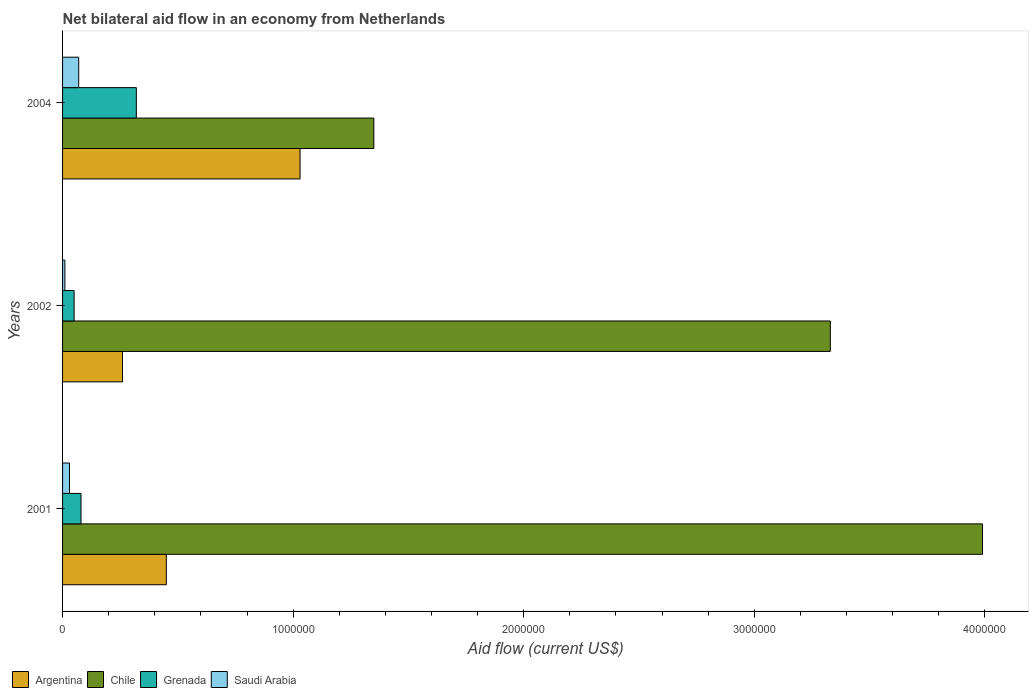How many groups of bars are there?
Your response must be concise. 3. Are the number of bars on each tick of the Y-axis equal?
Keep it short and to the point. Yes. What is the label of the 1st group of bars from the top?
Your answer should be very brief. 2004. In how many cases, is the number of bars for a given year not equal to the number of legend labels?
Provide a short and direct response. 0. What is the net bilateral aid flow in Argentina in 2004?
Ensure brevity in your answer.  1.03e+06. Across all years, what is the minimum net bilateral aid flow in Saudi Arabia?
Provide a short and direct response. 10000. In which year was the net bilateral aid flow in Argentina maximum?
Keep it short and to the point. 2004. What is the total net bilateral aid flow in Chile in the graph?
Keep it short and to the point. 8.67e+06. What is the difference between the net bilateral aid flow in Chile in 2004 and the net bilateral aid flow in Saudi Arabia in 2002?
Your answer should be very brief. 1.34e+06. What is the average net bilateral aid flow in Chile per year?
Keep it short and to the point. 2.89e+06. In the year 2001, what is the difference between the net bilateral aid flow in Argentina and net bilateral aid flow in Saudi Arabia?
Make the answer very short. 4.20e+05. In how many years, is the net bilateral aid flow in Chile greater than 1000000 US$?
Keep it short and to the point. 3. What is the ratio of the net bilateral aid flow in Grenada in 2001 to that in 2002?
Offer a very short reply. 1.6. Is the net bilateral aid flow in Saudi Arabia in 2001 less than that in 2002?
Provide a short and direct response. No. Is the difference between the net bilateral aid flow in Argentina in 2001 and 2004 greater than the difference between the net bilateral aid flow in Saudi Arabia in 2001 and 2004?
Ensure brevity in your answer.  No. What is the difference between the highest and the second highest net bilateral aid flow in Saudi Arabia?
Keep it short and to the point. 4.00e+04. What is the difference between the highest and the lowest net bilateral aid flow in Chile?
Ensure brevity in your answer.  2.64e+06. In how many years, is the net bilateral aid flow in Argentina greater than the average net bilateral aid flow in Argentina taken over all years?
Your response must be concise. 1. Is the sum of the net bilateral aid flow in Grenada in 2002 and 2004 greater than the maximum net bilateral aid flow in Chile across all years?
Give a very brief answer. No. What does the 1st bar from the top in 2001 represents?
Give a very brief answer. Saudi Arabia. What does the 2nd bar from the bottom in 2004 represents?
Make the answer very short. Chile. Is it the case that in every year, the sum of the net bilateral aid flow in Saudi Arabia and net bilateral aid flow in Grenada is greater than the net bilateral aid flow in Chile?
Give a very brief answer. No. Are all the bars in the graph horizontal?
Provide a short and direct response. Yes. What is the difference between two consecutive major ticks on the X-axis?
Give a very brief answer. 1.00e+06. Are the values on the major ticks of X-axis written in scientific E-notation?
Your answer should be compact. No. Does the graph contain any zero values?
Provide a short and direct response. No. How are the legend labels stacked?
Your answer should be very brief. Horizontal. What is the title of the graph?
Provide a short and direct response. Net bilateral aid flow in an economy from Netherlands. What is the label or title of the X-axis?
Offer a very short reply. Aid flow (current US$). What is the Aid flow (current US$) in Chile in 2001?
Your answer should be very brief. 3.99e+06. What is the Aid flow (current US$) in Grenada in 2001?
Give a very brief answer. 8.00e+04. What is the Aid flow (current US$) in Saudi Arabia in 2001?
Offer a very short reply. 3.00e+04. What is the Aid flow (current US$) of Argentina in 2002?
Offer a very short reply. 2.60e+05. What is the Aid flow (current US$) in Chile in 2002?
Your answer should be very brief. 3.33e+06. What is the Aid flow (current US$) of Grenada in 2002?
Your answer should be compact. 5.00e+04. What is the Aid flow (current US$) in Saudi Arabia in 2002?
Offer a terse response. 10000. What is the Aid flow (current US$) in Argentina in 2004?
Give a very brief answer. 1.03e+06. What is the Aid flow (current US$) of Chile in 2004?
Your response must be concise. 1.35e+06. Across all years, what is the maximum Aid flow (current US$) of Argentina?
Offer a very short reply. 1.03e+06. Across all years, what is the maximum Aid flow (current US$) in Chile?
Keep it short and to the point. 3.99e+06. Across all years, what is the minimum Aid flow (current US$) in Chile?
Ensure brevity in your answer.  1.35e+06. Across all years, what is the minimum Aid flow (current US$) in Saudi Arabia?
Your answer should be compact. 10000. What is the total Aid flow (current US$) in Argentina in the graph?
Your answer should be very brief. 1.74e+06. What is the total Aid flow (current US$) in Chile in the graph?
Your response must be concise. 8.67e+06. What is the total Aid flow (current US$) in Grenada in the graph?
Ensure brevity in your answer.  4.50e+05. What is the total Aid flow (current US$) in Saudi Arabia in the graph?
Your answer should be compact. 1.10e+05. What is the difference between the Aid flow (current US$) of Argentina in 2001 and that in 2002?
Ensure brevity in your answer.  1.90e+05. What is the difference between the Aid flow (current US$) of Chile in 2001 and that in 2002?
Make the answer very short. 6.60e+05. What is the difference between the Aid flow (current US$) in Saudi Arabia in 2001 and that in 2002?
Your answer should be very brief. 2.00e+04. What is the difference between the Aid flow (current US$) in Argentina in 2001 and that in 2004?
Make the answer very short. -5.80e+05. What is the difference between the Aid flow (current US$) of Chile in 2001 and that in 2004?
Your response must be concise. 2.64e+06. What is the difference between the Aid flow (current US$) in Saudi Arabia in 2001 and that in 2004?
Offer a terse response. -4.00e+04. What is the difference between the Aid flow (current US$) in Argentina in 2002 and that in 2004?
Keep it short and to the point. -7.70e+05. What is the difference between the Aid flow (current US$) of Chile in 2002 and that in 2004?
Offer a terse response. 1.98e+06. What is the difference between the Aid flow (current US$) of Saudi Arabia in 2002 and that in 2004?
Ensure brevity in your answer.  -6.00e+04. What is the difference between the Aid flow (current US$) in Argentina in 2001 and the Aid flow (current US$) in Chile in 2002?
Ensure brevity in your answer.  -2.88e+06. What is the difference between the Aid flow (current US$) in Argentina in 2001 and the Aid flow (current US$) in Grenada in 2002?
Provide a short and direct response. 4.00e+05. What is the difference between the Aid flow (current US$) in Chile in 2001 and the Aid flow (current US$) in Grenada in 2002?
Offer a very short reply. 3.94e+06. What is the difference between the Aid flow (current US$) of Chile in 2001 and the Aid flow (current US$) of Saudi Arabia in 2002?
Give a very brief answer. 3.98e+06. What is the difference between the Aid flow (current US$) in Argentina in 2001 and the Aid flow (current US$) in Chile in 2004?
Give a very brief answer. -9.00e+05. What is the difference between the Aid flow (current US$) in Chile in 2001 and the Aid flow (current US$) in Grenada in 2004?
Give a very brief answer. 3.67e+06. What is the difference between the Aid flow (current US$) in Chile in 2001 and the Aid flow (current US$) in Saudi Arabia in 2004?
Your response must be concise. 3.92e+06. What is the difference between the Aid flow (current US$) in Grenada in 2001 and the Aid flow (current US$) in Saudi Arabia in 2004?
Offer a terse response. 10000. What is the difference between the Aid flow (current US$) in Argentina in 2002 and the Aid flow (current US$) in Chile in 2004?
Provide a short and direct response. -1.09e+06. What is the difference between the Aid flow (current US$) of Argentina in 2002 and the Aid flow (current US$) of Grenada in 2004?
Your response must be concise. -6.00e+04. What is the difference between the Aid flow (current US$) in Argentina in 2002 and the Aid flow (current US$) in Saudi Arabia in 2004?
Provide a succinct answer. 1.90e+05. What is the difference between the Aid flow (current US$) in Chile in 2002 and the Aid flow (current US$) in Grenada in 2004?
Your response must be concise. 3.01e+06. What is the difference between the Aid flow (current US$) in Chile in 2002 and the Aid flow (current US$) in Saudi Arabia in 2004?
Provide a succinct answer. 3.26e+06. What is the difference between the Aid flow (current US$) of Grenada in 2002 and the Aid flow (current US$) of Saudi Arabia in 2004?
Make the answer very short. -2.00e+04. What is the average Aid flow (current US$) in Argentina per year?
Provide a short and direct response. 5.80e+05. What is the average Aid flow (current US$) in Chile per year?
Your answer should be very brief. 2.89e+06. What is the average Aid flow (current US$) in Saudi Arabia per year?
Your response must be concise. 3.67e+04. In the year 2001, what is the difference between the Aid flow (current US$) of Argentina and Aid flow (current US$) of Chile?
Your response must be concise. -3.54e+06. In the year 2001, what is the difference between the Aid flow (current US$) in Argentina and Aid flow (current US$) in Grenada?
Offer a very short reply. 3.70e+05. In the year 2001, what is the difference between the Aid flow (current US$) of Chile and Aid flow (current US$) of Grenada?
Your answer should be very brief. 3.91e+06. In the year 2001, what is the difference between the Aid flow (current US$) of Chile and Aid flow (current US$) of Saudi Arabia?
Offer a terse response. 3.96e+06. In the year 2001, what is the difference between the Aid flow (current US$) in Grenada and Aid flow (current US$) in Saudi Arabia?
Keep it short and to the point. 5.00e+04. In the year 2002, what is the difference between the Aid flow (current US$) of Argentina and Aid flow (current US$) of Chile?
Provide a succinct answer. -3.07e+06. In the year 2002, what is the difference between the Aid flow (current US$) of Argentina and Aid flow (current US$) of Saudi Arabia?
Make the answer very short. 2.50e+05. In the year 2002, what is the difference between the Aid flow (current US$) in Chile and Aid flow (current US$) in Grenada?
Offer a terse response. 3.28e+06. In the year 2002, what is the difference between the Aid flow (current US$) in Chile and Aid flow (current US$) in Saudi Arabia?
Your answer should be compact. 3.32e+06. In the year 2002, what is the difference between the Aid flow (current US$) of Grenada and Aid flow (current US$) of Saudi Arabia?
Your response must be concise. 4.00e+04. In the year 2004, what is the difference between the Aid flow (current US$) in Argentina and Aid flow (current US$) in Chile?
Offer a very short reply. -3.20e+05. In the year 2004, what is the difference between the Aid flow (current US$) of Argentina and Aid flow (current US$) of Grenada?
Your answer should be very brief. 7.10e+05. In the year 2004, what is the difference between the Aid flow (current US$) in Argentina and Aid flow (current US$) in Saudi Arabia?
Make the answer very short. 9.60e+05. In the year 2004, what is the difference between the Aid flow (current US$) of Chile and Aid flow (current US$) of Grenada?
Offer a very short reply. 1.03e+06. In the year 2004, what is the difference between the Aid flow (current US$) of Chile and Aid flow (current US$) of Saudi Arabia?
Ensure brevity in your answer.  1.28e+06. What is the ratio of the Aid flow (current US$) of Argentina in 2001 to that in 2002?
Your answer should be compact. 1.73. What is the ratio of the Aid flow (current US$) of Chile in 2001 to that in 2002?
Make the answer very short. 1.2. What is the ratio of the Aid flow (current US$) in Grenada in 2001 to that in 2002?
Offer a terse response. 1.6. What is the ratio of the Aid flow (current US$) in Argentina in 2001 to that in 2004?
Ensure brevity in your answer.  0.44. What is the ratio of the Aid flow (current US$) of Chile in 2001 to that in 2004?
Offer a terse response. 2.96. What is the ratio of the Aid flow (current US$) of Grenada in 2001 to that in 2004?
Your answer should be compact. 0.25. What is the ratio of the Aid flow (current US$) in Saudi Arabia in 2001 to that in 2004?
Provide a succinct answer. 0.43. What is the ratio of the Aid flow (current US$) in Argentina in 2002 to that in 2004?
Offer a terse response. 0.25. What is the ratio of the Aid flow (current US$) in Chile in 2002 to that in 2004?
Give a very brief answer. 2.47. What is the ratio of the Aid flow (current US$) in Grenada in 2002 to that in 2004?
Keep it short and to the point. 0.16. What is the ratio of the Aid flow (current US$) of Saudi Arabia in 2002 to that in 2004?
Provide a succinct answer. 0.14. What is the difference between the highest and the second highest Aid flow (current US$) of Argentina?
Ensure brevity in your answer.  5.80e+05. What is the difference between the highest and the second highest Aid flow (current US$) in Chile?
Provide a short and direct response. 6.60e+05. What is the difference between the highest and the second highest Aid flow (current US$) in Saudi Arabia?
Your response must be concise. 4.00e+04. What is the difference between the highest and the lowest Aid flow (current US$) of Argentina?
Ensure brevity in your answer.  7.70e+05. What is the difference between the highest and the lowest Aid flow (current US$) of Chile?
Make the answer very short. 2.64e+06. What is the difference between the highest and the lowest Aid flow (current US$) of Grenada?
Keep it short and to the point. 2.70e+05. What is the difference between the highest and the lowest Aid flow (current US$) in Saudi Arabia?
Your answer should be very brief. 6.00e+04. 